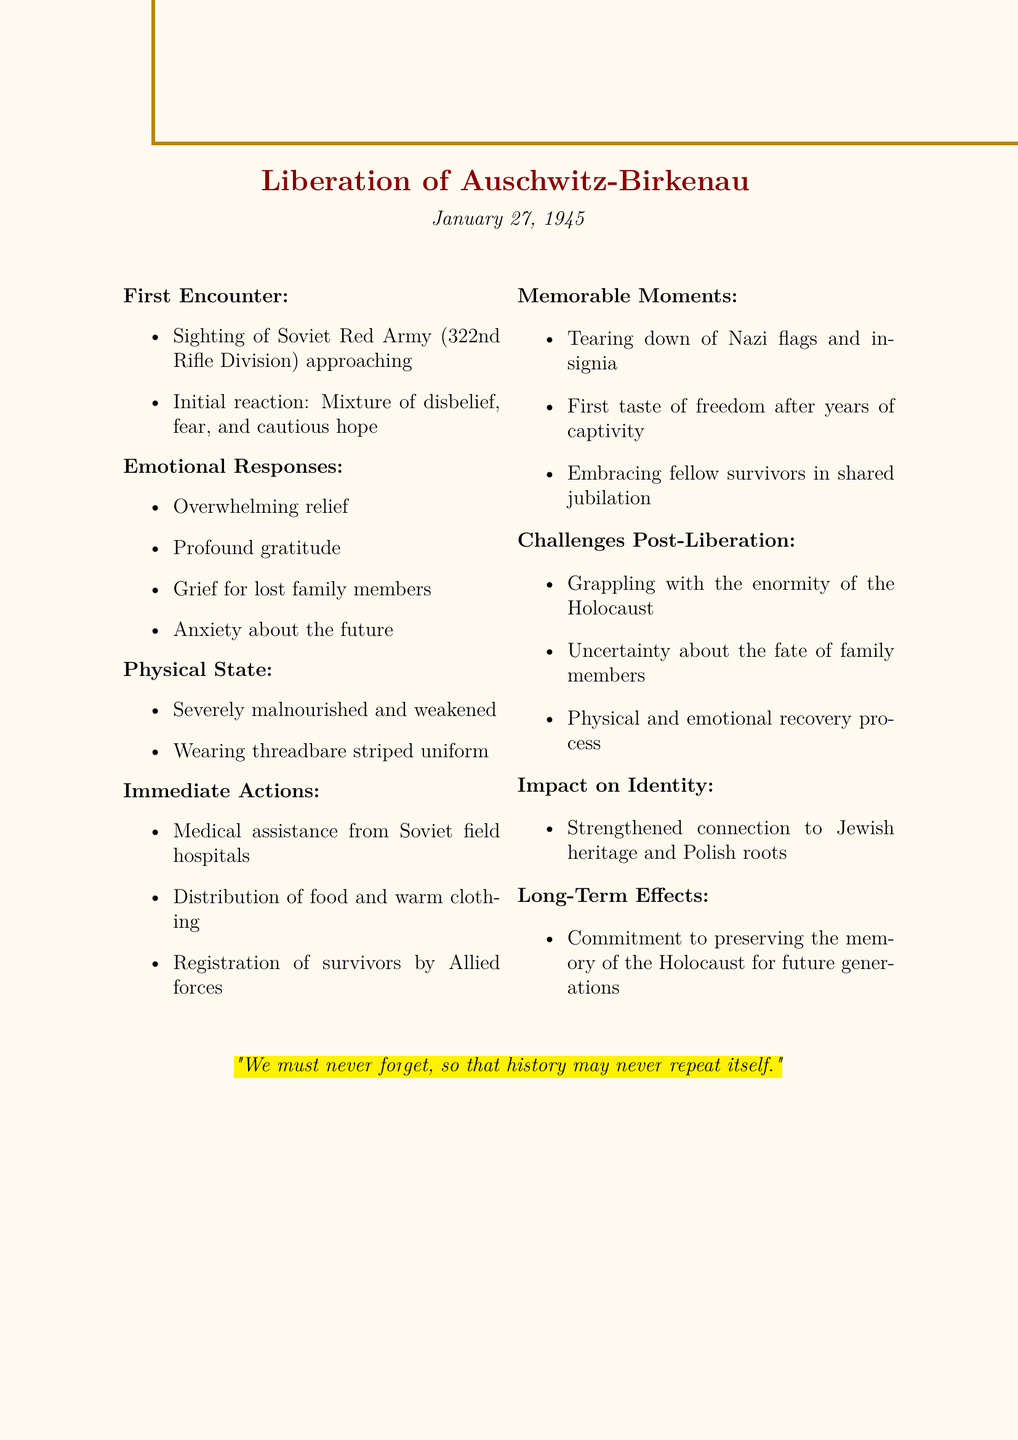what is the liberation date? The liberation date is stated clearly in the document as January 27, 1945.
Answer: January 27, 1945 who were the liberating forces? The document specifies that the liberating forces were the Soviet Red Army, 322nd Rifle Division.
Answer: Soviet Red Army, 322nd Rifle Division what was the initial reaction to the soldiers' arrival? The initial reaction described in the document was a mixture of disbelief, fear, and cautious hope.
Answer: Mixture of disbelief, fear, and cautious hope name one memorable moment after liberation. The document lists several memorable moments, one of which is the tearing down of Nazi flags and insignia.
Answer: Tearing down of Nazi flags and insignia what challenges were faced post-liberation? The document notes several challenges faced post-liberation, such as grappling with the enormity of the Holocaust.
Answer: Grappling with the enormity of the Holocaust how did liberation impact identity? The document states that liberation strengthened the connection to Jewish heritage and Polish roots.
Answer: Strengthened connection to Jewish heritage and Polish roots what was the physical state of survivors at liberation? The document indicates that survivors were severely malnourished and weakened.
Answer: Severely malnourished and weakened what was provided immediately after liberation? According to the document, immediate actions included medical assistance from Soviet field hospitals.
Answer: Medical assistance from Soviet field hospitals 